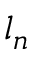Convert formula to latex. <formula><loc_0><loc_0><loc_500><loc_500>l _ { n }</formula> 